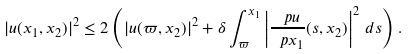Convert formula to latex. <formula><loc_0><loc_0><loc_500><loc_500>| u ( x _ { 1 } , x _ { 2 } ) | ^ { 2 } \leq 2 \left ( | u ( \varpi , x _ { 2 } ) | ^ { 2 } + \delta \int _ { \varpi } ^ { x _ { 1 } } \left | \frac { \ p u } { \ p x _ { 1 } } ( s , x _ { 2 } ) \right | ^ { 2 } \, d s \right ) .</formula> 